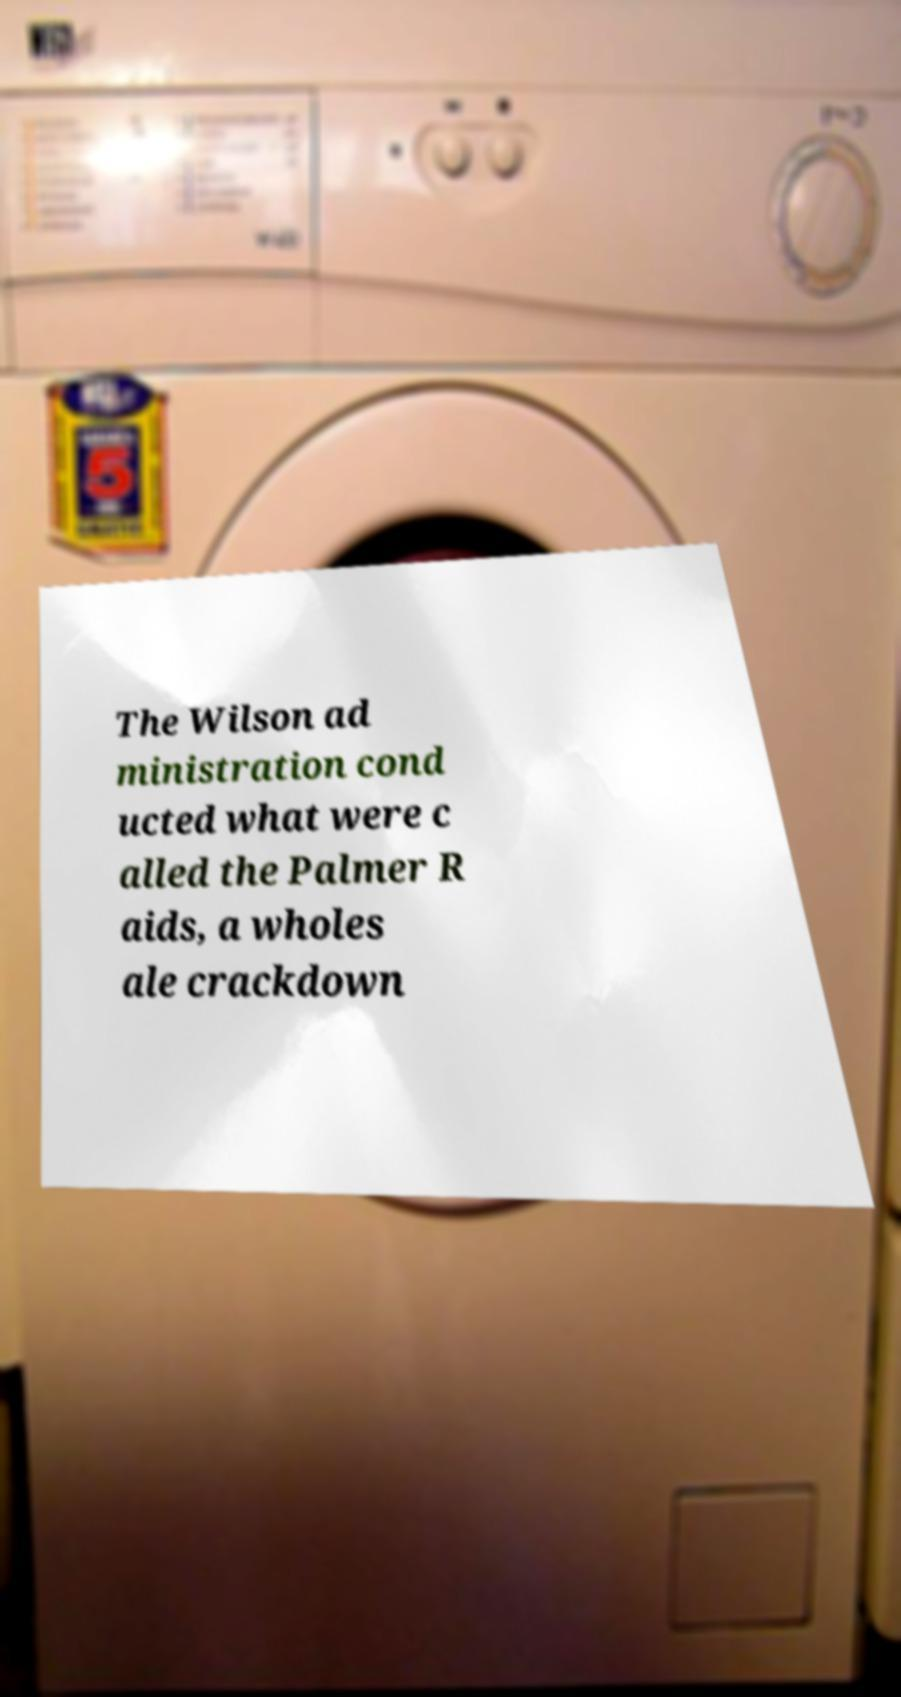For documentation purposes, I need the text within this image transcribed. Could you provide that? The Wilson ad ministration cond ucted what were c alled the Palmer R aids, a wholes ale crackdown 